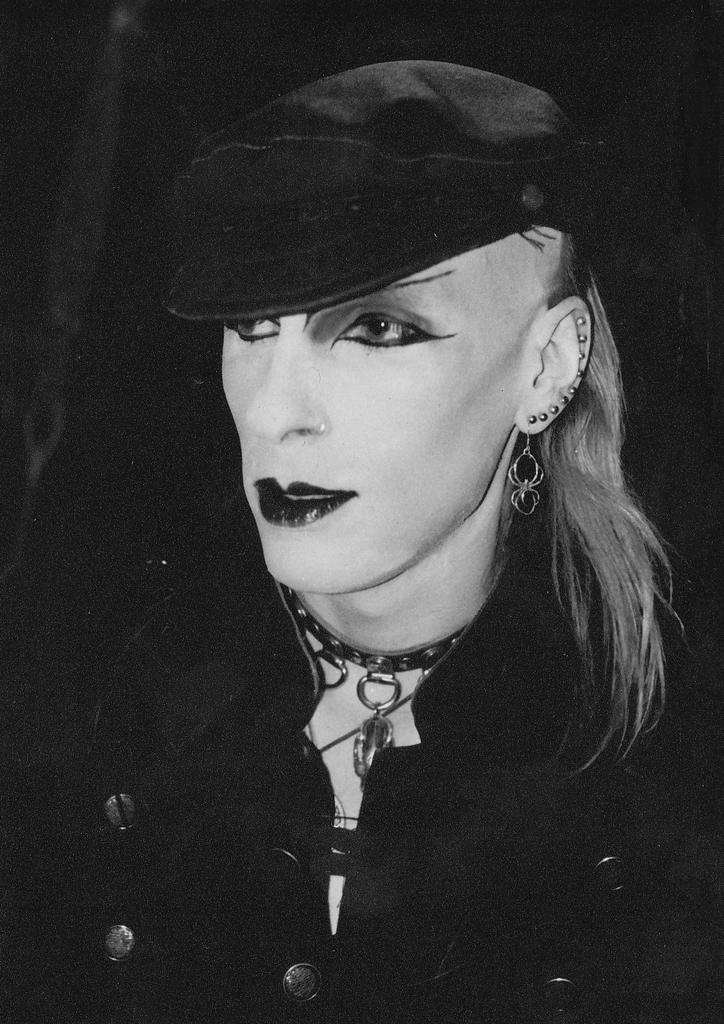What is the main subject of the image? There is a person in the image. What else can be seen in the image besides the person? There is jewellery in the image. What is the color scheme of the image? The image is in black and white. What type of company is depicted in the image? There is no company depicted in the image; it features a person and jewellery. How many bubbles can be seen in the image? There are no bubbles present in the image. 